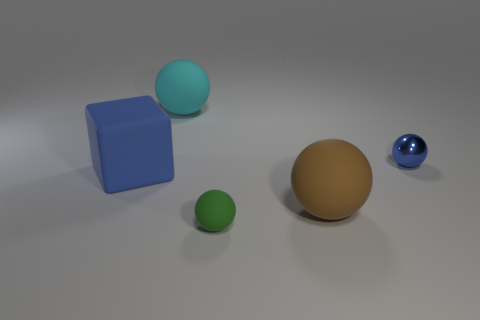Are there any other things that have the same material as the tiny blue thing?
Provide a succinct answer. No. Is the color of the cube the same as the shiny thing?
Give a very brief answer. Yes. What number of big brown things have the same shape as the tiny blue object?
Your response must be concise. 1. The ball that is both right of the green sphere and behind the blue rubber object is what color?
Your answer should be very brief. Blue. How many red metal balls are there?
Offer a terse response. 0. Do the metal sphere and the green rubber ball have the same size?
Make the answer very short. Yes. Is there a tiny ball that has the same color as the large cube?
Offer a terse response. Yes. There is a thing behind the tiny metal sphere; is it the same shape as the big brown rubber object?
Your response must be concise. Yes. What number of other cyan matte balls are the same size as the cyan sphere?
Provide a short and direct response. 0. How many small blue balls are behind the big matte sphere in front of the cyan thing?
Ensure brevity in your answer.  1. 